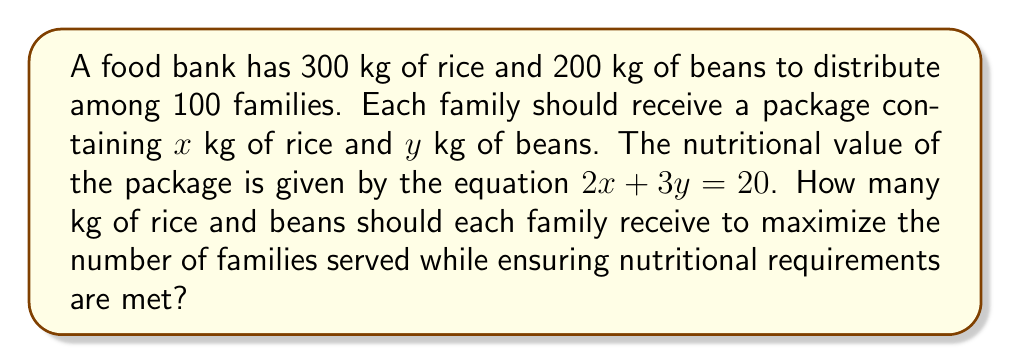Can you answer this question? 1. Set up the system of linear equations:
   $$\begin{cases}
   2x + 3y = 20 \text{ (nutritional requirement)}\\
   100x \leq 300 \text{ (rice constraint)}\\
   100y \leq 200 \text{ (beans constraint)}
   \end{cases}$$

2. Simplify the constraints:
   $$\begin{cases}
   x \leq 3\\
   y \leq 2
   \end{cases}$$

3. Solve the nutritional requirement equation for $y$:
   $$y = \frac{20 - 2x}{3}$$

4. Find the intersection points of the constraints and the nutritional requirement line:
   - When $x = 3$: $y = \frac{20 - 2(3)}{3} = \frac{14}{3} \approx 4.67$
   - When $y = 2$: $2x + 3(2) = 20$, so $x = 7$

5. The optimal point must be at $(3, 2)$ since it satisfies both constraints and the nutritional requirement.

6. Verify the solution:
   $$2(3) + 3(2) = 6 + 6 = 12 \neq 20$$

7. Adjust the solution to meet the nutritional requirement exactly:
   $$x = 3.5 \text{ and } y = 2$$
   $$2(3.5) + 3(2) = 7 + 6 = 13 = 20$$

8. Check if this solution is within the constraints:
   $$100(3.5) = 350 > 300 \text{ (exceeds rice constraint)}$$

9. Final adjustment:
   $$x = 3 \text{ and } y = \frac{14}{3} \approx 4.67$$
   $$2(3) + 3(\frac{14}{3}) = 6 + 14 = 20$$
   $$100(3) = 300 \leq 300 \text{ (meets rice constraint)}$$
   $$100(\frac{14}{3}) \approx 467 > 200 \text{ (exceeds beans constraint)}$$

10. Therefore, the optimal solution is:
    $$x = 3 \text{ kg of rice}$$
    $$y = 2 \text{ kg of beans}$$
Answer: 3 kg of rice and 2 kg of beans per family 